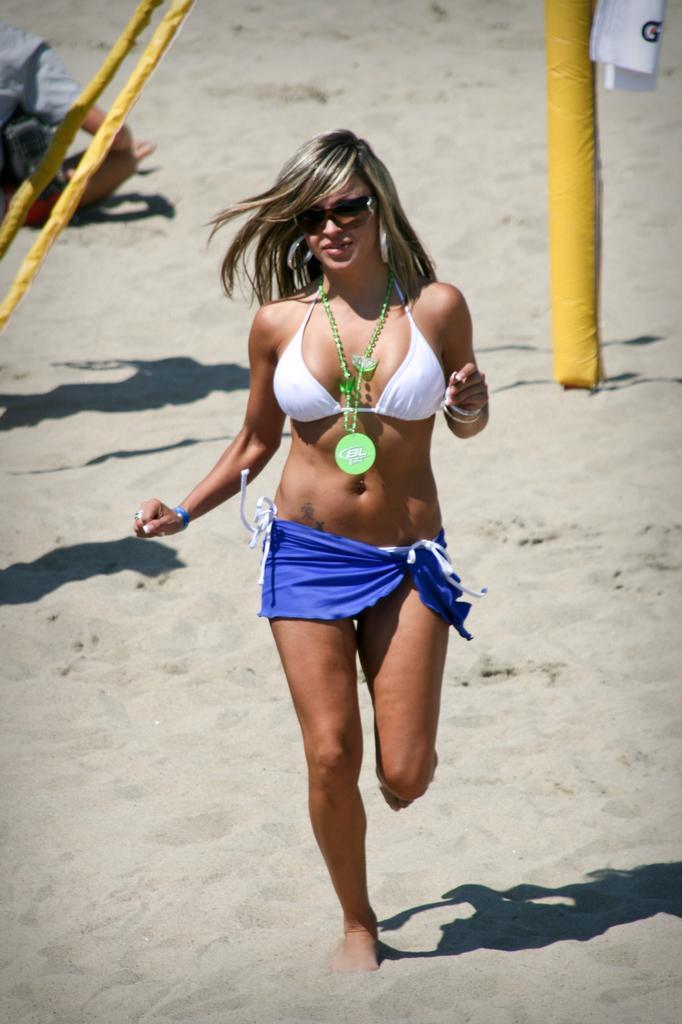How would you summarize this image in a sentence or two? There is a woman running on the sand,behind this woman we can see yellow objects and there is a person sitting. 